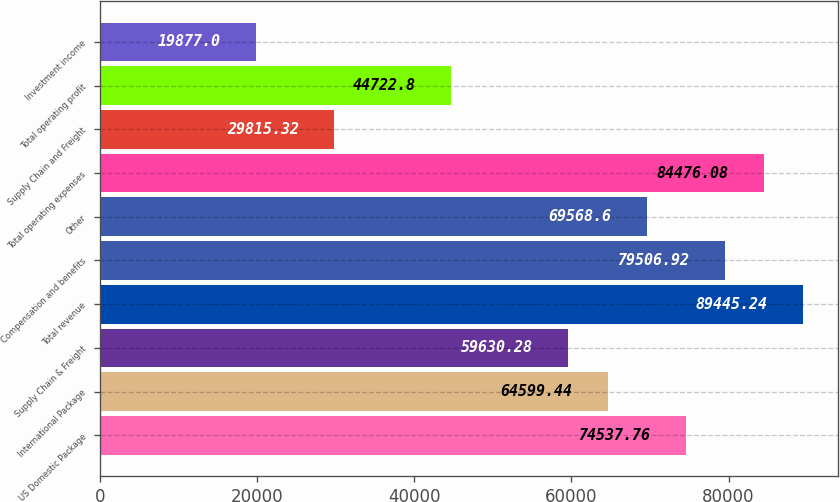Convert chart to OTSL. <chart><loc_0><loc_0><loc_500><loc_500><bar_chart><fcel>US Domestic Package<fcel>International Package<fcel>Supply Chain & Freight<fcel>Total revenue<fcel>Compensation and benefits<fcel>Other<fcel>Total operating expenses<fcel>Supply Chain and Freight<fcel>Total operating profit<fcel>Investment income<nl><fcel>74537.8<fcel>64599.4<fcel>59630.3<fcel>89445.2<fcel>79506.9<fcel>69568.6<fcel>84476.1<fcel>29815.3<fcel>44722.8<fcel>19877<nl></chart> 